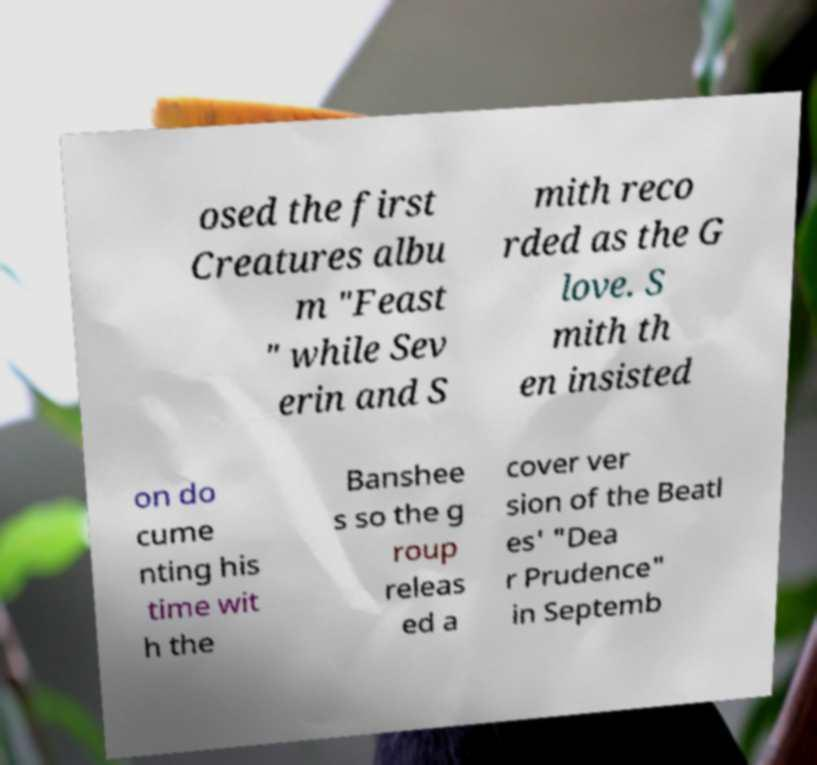Please identify and transcribe the text found in this image. osed the first Creatures albu m "Feast " while Sev erin and S mith reco rded as the G love. S mith th en insisted on do cume nting his time wit h the Banshee s so the g roup releas ed a cover ver sion of the Beatl es' "Dea r Prudence" in Septemb 